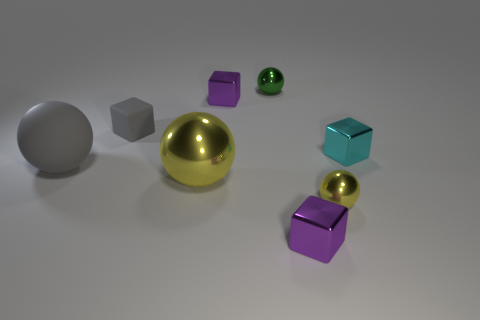The tiny shiny object that is in front of the tiny green object and behind the small matte object is what color?
Your response must be concise. Purple. What size is the cyan metallic block?
Ensure brevity in your answer.  Small. There is a large thing that is to the right of the tiny gray cube; does it have the same color as the big matte thing?
Keep it short and to the point. No. Is the number of small green objects that are in front of the cyan thing greater than the number of cyan shiny objects that are behind the gray rubber block?
Keep it short and to the point. No. Are there more big gray rubber balls than purple objects?
Ensure brevity in your answer.  No. How big is the ball that is both behind the large yellow object and to the right of the small gray matte cube?
Offer a terse response. Small. There is a small green thing; what shape is it?
Your answer should be compact. Sphere. Are there any other things that are the same size as the cyan object?
Provide a short and direct response. Yes. Is the number of tiny yellow metal balls to the left of the large gray matte object greater than the number of shiny cubes?
Give a very brief answer. No. What shape is the purple metallic thing that is in front of the yellow sphere that is to the left of the purple metal thing that is behind the cyan block?
Provide a short and direct response. Cube. 